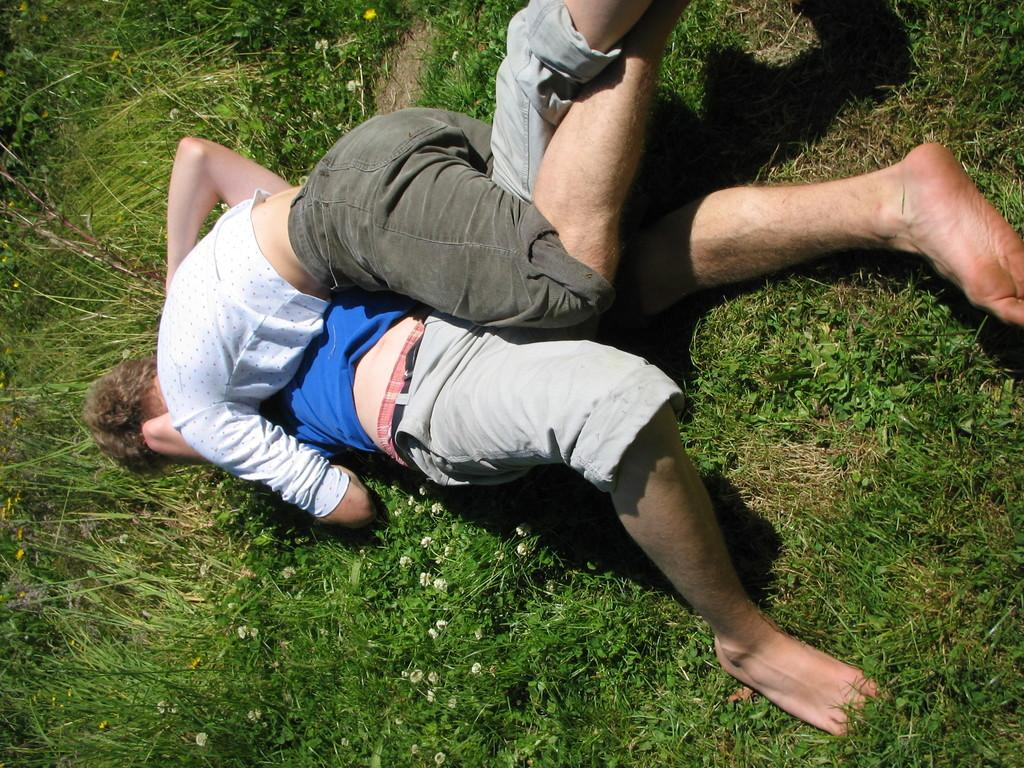What type of terrain is visible at the bottom of the picture? There is grass visible at the bottom of the picture. How many people are in the image? There are two persons in the image. What are the two persons doing in the image? The two persons appear to be fighting. What type of sister can be seen attending the church in the image? There is no sister or church present in the image; it features two persons fighting on grass. What type of net is being used by the persons in the image? There is no net present in the image; the two persons are fighting without any visible equipment. 